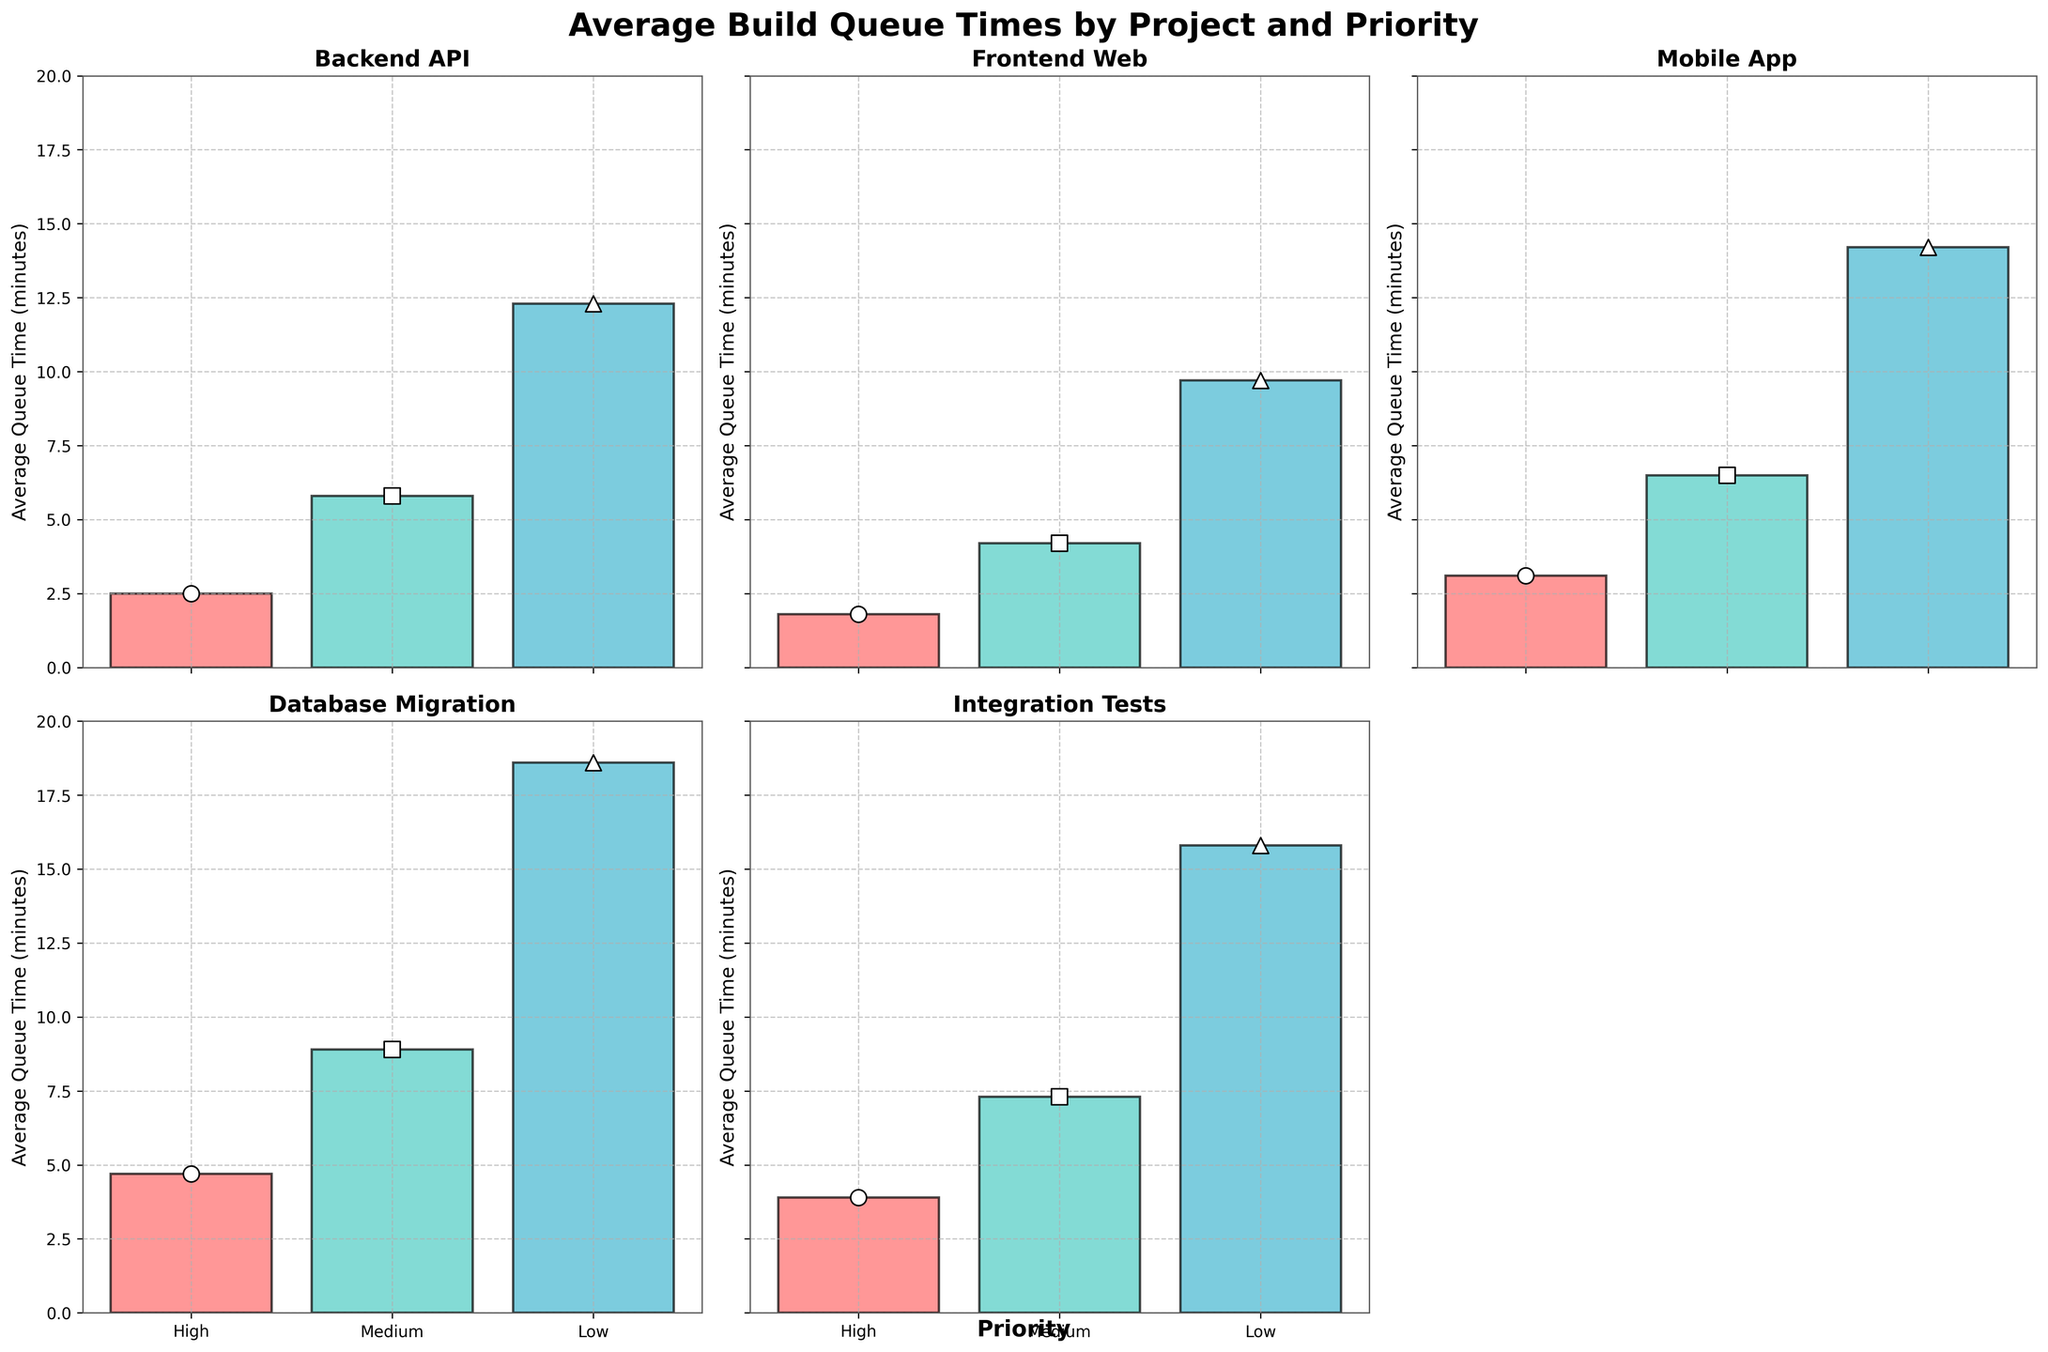What is the average build queue time for the Backend API project with high priority? The subplot titled "Backend API" illustrates that the bar representing high priority (colored red) indicates a value. By reading that bar, the average queue time for high priority is 2.5 minutes.
Answer: 2.5 minutes What color represents medium priority tasks in the subplots? According to the legend in the subplots, medium priority is consistently represented by a teal color.
Answer: Teal Which project has the highest average build queue time for low priority tasks? Comparing all the subplots, we see that the "Database Migration" project has the tallest bar for low priority, which is marked at 18.6 minutes.
Answer: Database Migration How many projects have an average build queue time for high priority tasks greater than 3 minutes? Examining each subplot, we see that the "Mobile App," "Database Migration," and "Integration Tests" projects all have bars for high priority above the 3-minute mark. We count 3 projects in total.
Answer: 3 projects What is the difference in average build queue time for medium priority tasks between the Backend API and Frontend Web projects? The subplot for "Backend API" shows a medium priority queue time of 5.8 minutes, and the "Frontend Web" subplot shows 4.2 minutes. The difference is calculated as 5.8 - 4.2 = 1.6 minutes.
Answer: 1.6 minutes Which project has the shortest average build queue time for high priority tasks, and what is its value? By looking at the subplots, the "Frontend Web" project has the shortest bar for high priority, indicating a value of 1.8 minutes.
Answer: Frontend Web at 1.8 minutes What is the average of the average build queue times for all projects with medium priority? Summing the medium priority values: 5.8 (Backend API) + 4.2 (Frontend Web) + 6.5 (Mobile App) + 8.9 (Database Migration) + 7.3 (Integration Tests) = 32.7. Dividing by the number of projects (5), we get 32.7 / 5 = 6.54 minutes.
Answer: 6.54 minutes For the Mobile App project, how much longer is the average build queue time for low priority compared to high priority tasks? The Mobile App project’s average queue times are 14.2 minutes for low priority and 3.1 minutes for high priority. The difference is calculated as 14.2 - 3.1 = 11.1 minutes.
Answer: 11.1 minutes 